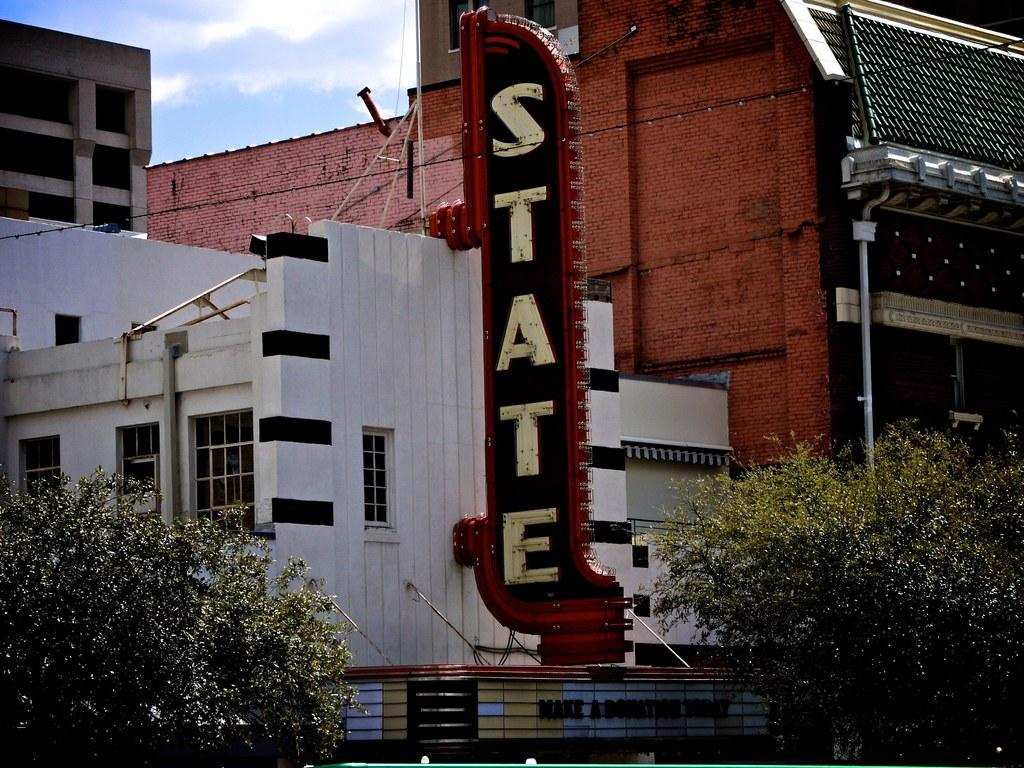What type of structures can be seen in the image? There are buildings in the image. What is present on the buildings in the image? There is a hoarding on the buildings in the image. What type of windows are on the buildings? There are glass windows in the image. What is in front of the buildings? There are trees in front of the buildings. How would you describe the sky in the image? The sky is cloudy in the image. What type of flowers are growing on the hoarding in the image? There are no flowers present on the hoarding in the image. 